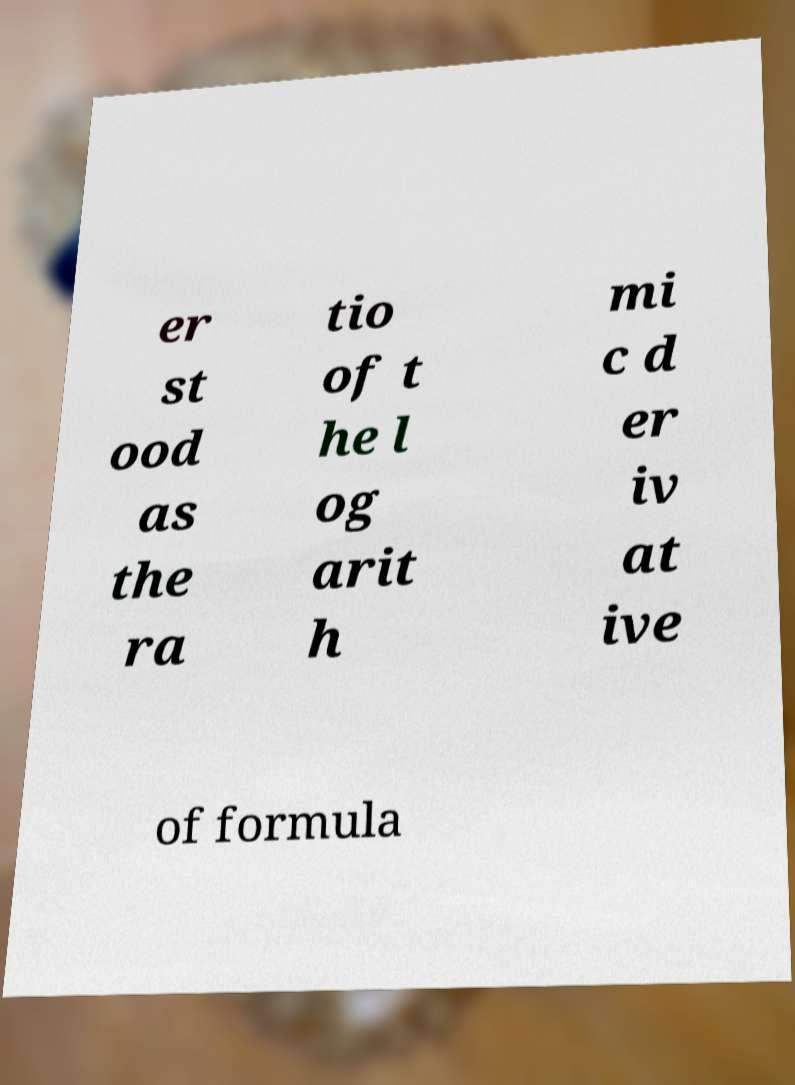Can you read and provide the text displayed in the image?This photo seems to have some interesting text. Can you extract and type it out for me? er st ood as the ra tio of t he l og arit h mi c d er iv at ive of formula 